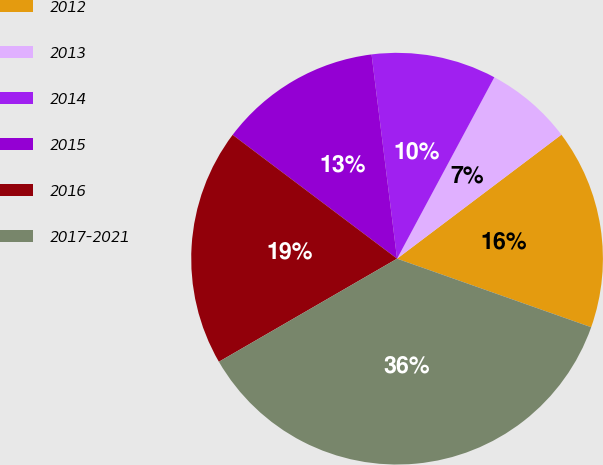<chart> <loc_0><loc_0><loc_500><loc_500><pie_chart><fcel>2012<fcel>2013<fcel>2014<fcel>2015<fcel>2016<fcel>2017-2021<nl><fcel>15.69%<fcel>6.88%<fcel>9.81%<fcel>12.75%<fcel>18.62%<fcel>36.25%<nl></chart> 